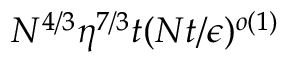<formula> <loc_0><loc_0><loc_500><loc_500>N ^ { 4 / 3 } \eta ^ { 7 / 3 } t ( N t / \epsilon ) ^ { o ( 1 ) }</formula> 